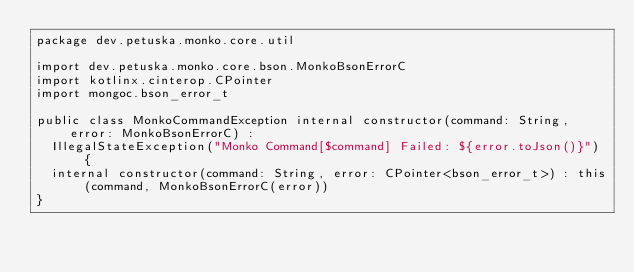Convert code to text. <code><loc_0><loc_0><loc_500><loc_500><_Kotlin_>package dev.petuska.monko.core.util

import dev.petuska.monko.core.bson.MonkoBsonErrorC
import kotlinx.cinterop.CPointer
import mongoc.bson_error_t

public class MonkoCommandException internal constructor(command: String, error: MonkoBsonErrorC) :
  IllegalStateException("Monko Command[$command] Failed: ${error.toJson()}") {
  internal constructor(command: String, error: CPointer<bson_error_t>) : this(command, MonkoBsonErrorC(error))
}
</code> 